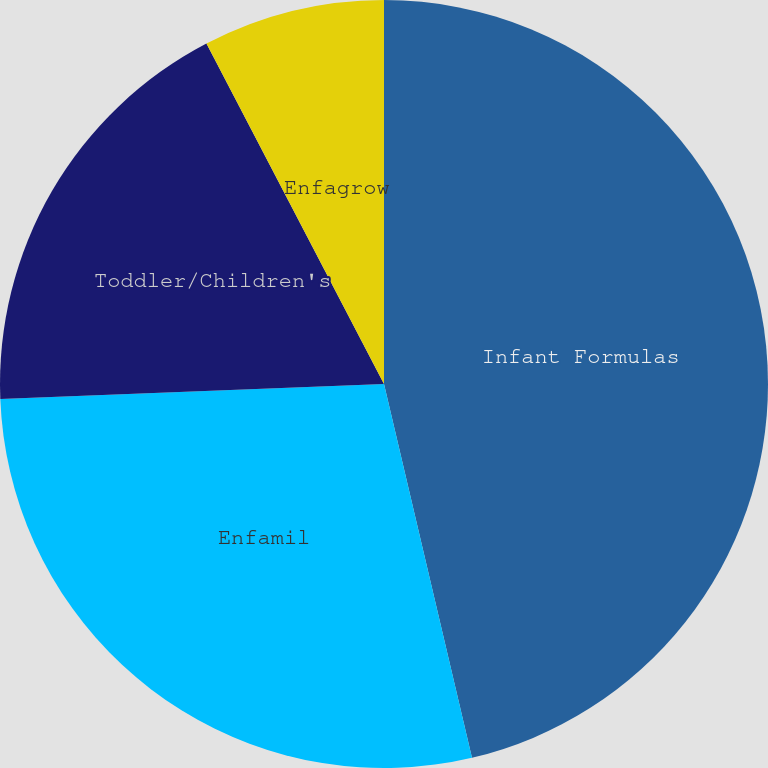Convert chart to OTSL. <chart><loc_0><loc_0><loc_500><loc_500><pie_chart><fcel>Infant Formulas<fcel>Enfamil<fcel>Toddler/Children's<fcel>Enfagrow<nl><fcel>46.32%<fcel>28.06%<fcel>17.97%<fcel>7.65%<nl></chart> 